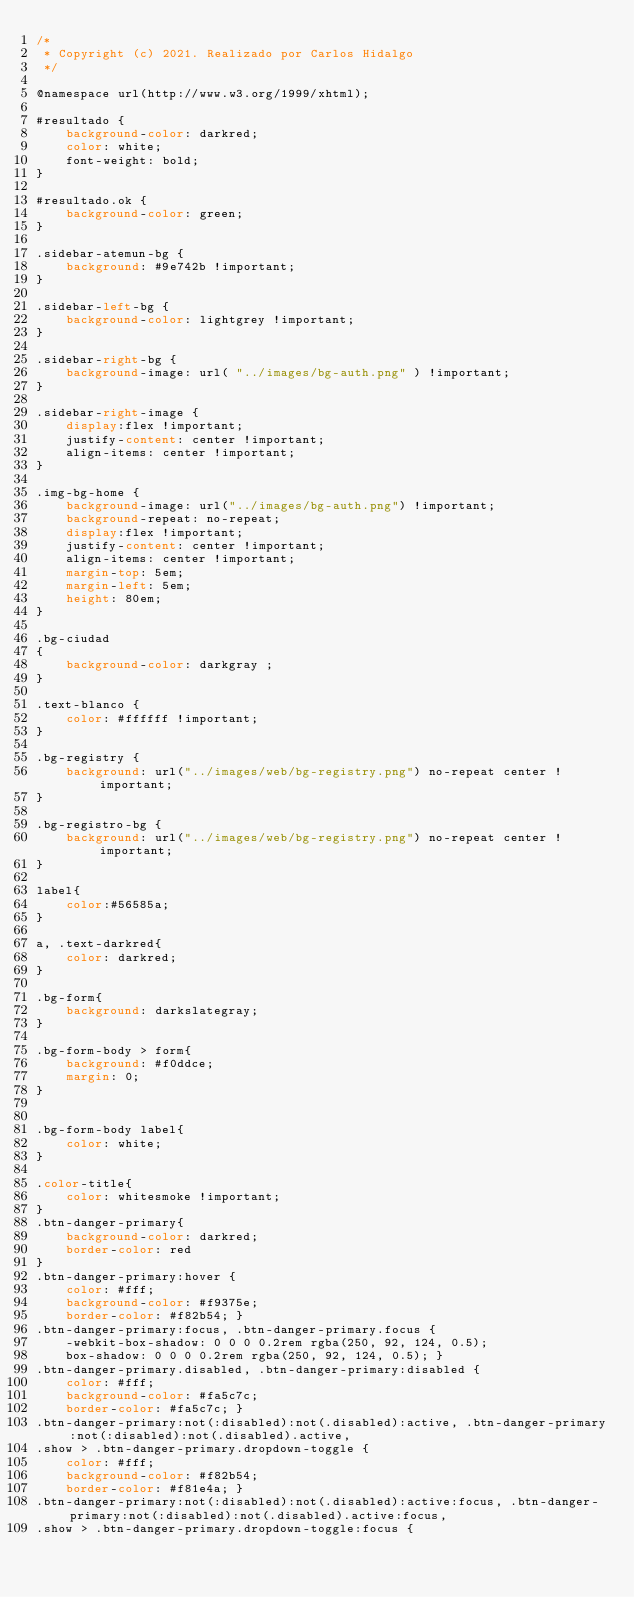Convert code to text. <code><loc_0><loc_0><loc_500><loc_500><_CSS_>/*
 * Copyright (c) 2021. Realizado por Carlos Hidalgo
 */

@namespace url(http://www.w3.org/1999/xhtml);

#resultado {
    background-color: darkred;
    color: white;
    font-weight: bold;
}

#resultado.ok {
    background-color: green;
}

.sidebar-atemun-bg {
    background: #9e742b !important;
}

.sidebar-left-bg {
    background-color: lightgrey !important;
}

.sidebar-right-bg {
    background-image: url( "../images/bg-auth.png" ) !important;
}

.sidebar-right-image {
    display:flex !important;
    justify-content: center !important;
    align-items: center !important;
}

.img-bg-home {
    background-image: url("../images/bg-auth.png") !important;
    background-repeat: no-repeat;
    display:flex !important;
    justify-content: center !important;
    align-items: center !important;
    margin-top: 5em;
    margin-left: 5em;
    height: 80em;
}

.bg-ciudad
{
    background-color: darkgray ;
}

.text-blanco {
    color: #ffffff !important;
}

.bg-registry {
    background: url("../images/web/bg-registry.png") no-repeat center !important;
}

.bg-registro-bg {
    background: url("../images/web/bg-registry.png") no-repeat center !important;
}

label{
    color:#56585a;
}

a, .text-darkred{
    color: darkred;
}

.bg-form{
    background: darkslategray;
}

.bg-form-body > form{
    background: #f0ddce;
    margin: 0;
}


.bg-form-body label{
    color: white;
}

.color-title{
    color: whitesmoke !important;
}
.btn-danger-primary{
    background-color: darkred;
    border-color: red
}
.btn-danger-primary:hover {
    color: #fff;
    background-color: #f9375e;
    border-color: #f82b54; }
.btn-danger-primary:focus, .btn-danger-primary.focus {
    -webkit-box-shadow: 0 0 0 0.2rem rgba(250, 92, 124, 0.5);
    box-shadow: 0 0 0 0.2rem rgba(250, 92, 124, 0.5); }
.btn-danger-primary.disabled, .btn-danger-primary:disabled {
    color: #fff;
    background-color: #fa5c7c;
    border-color: #fa5c7c; }
.btn-danger-primary:not(:disabled):not(.disabled):active, .btn-danger-primary:not(:disabled):not(.disabled).active,
.show > .btn-danger-primary.dropdown-toggle {
    color: #fff;
    background-color: #f82b54;
    border-color: #f81e4a; }
.btn-danger-primary:not(:disabled):not(.disabled):active:focus, .btn-danger-primary:not(:disabled):not(.disabled).active:focus,
.show > .btn-danger-primary.dropdown-toggle:focus {</code> 